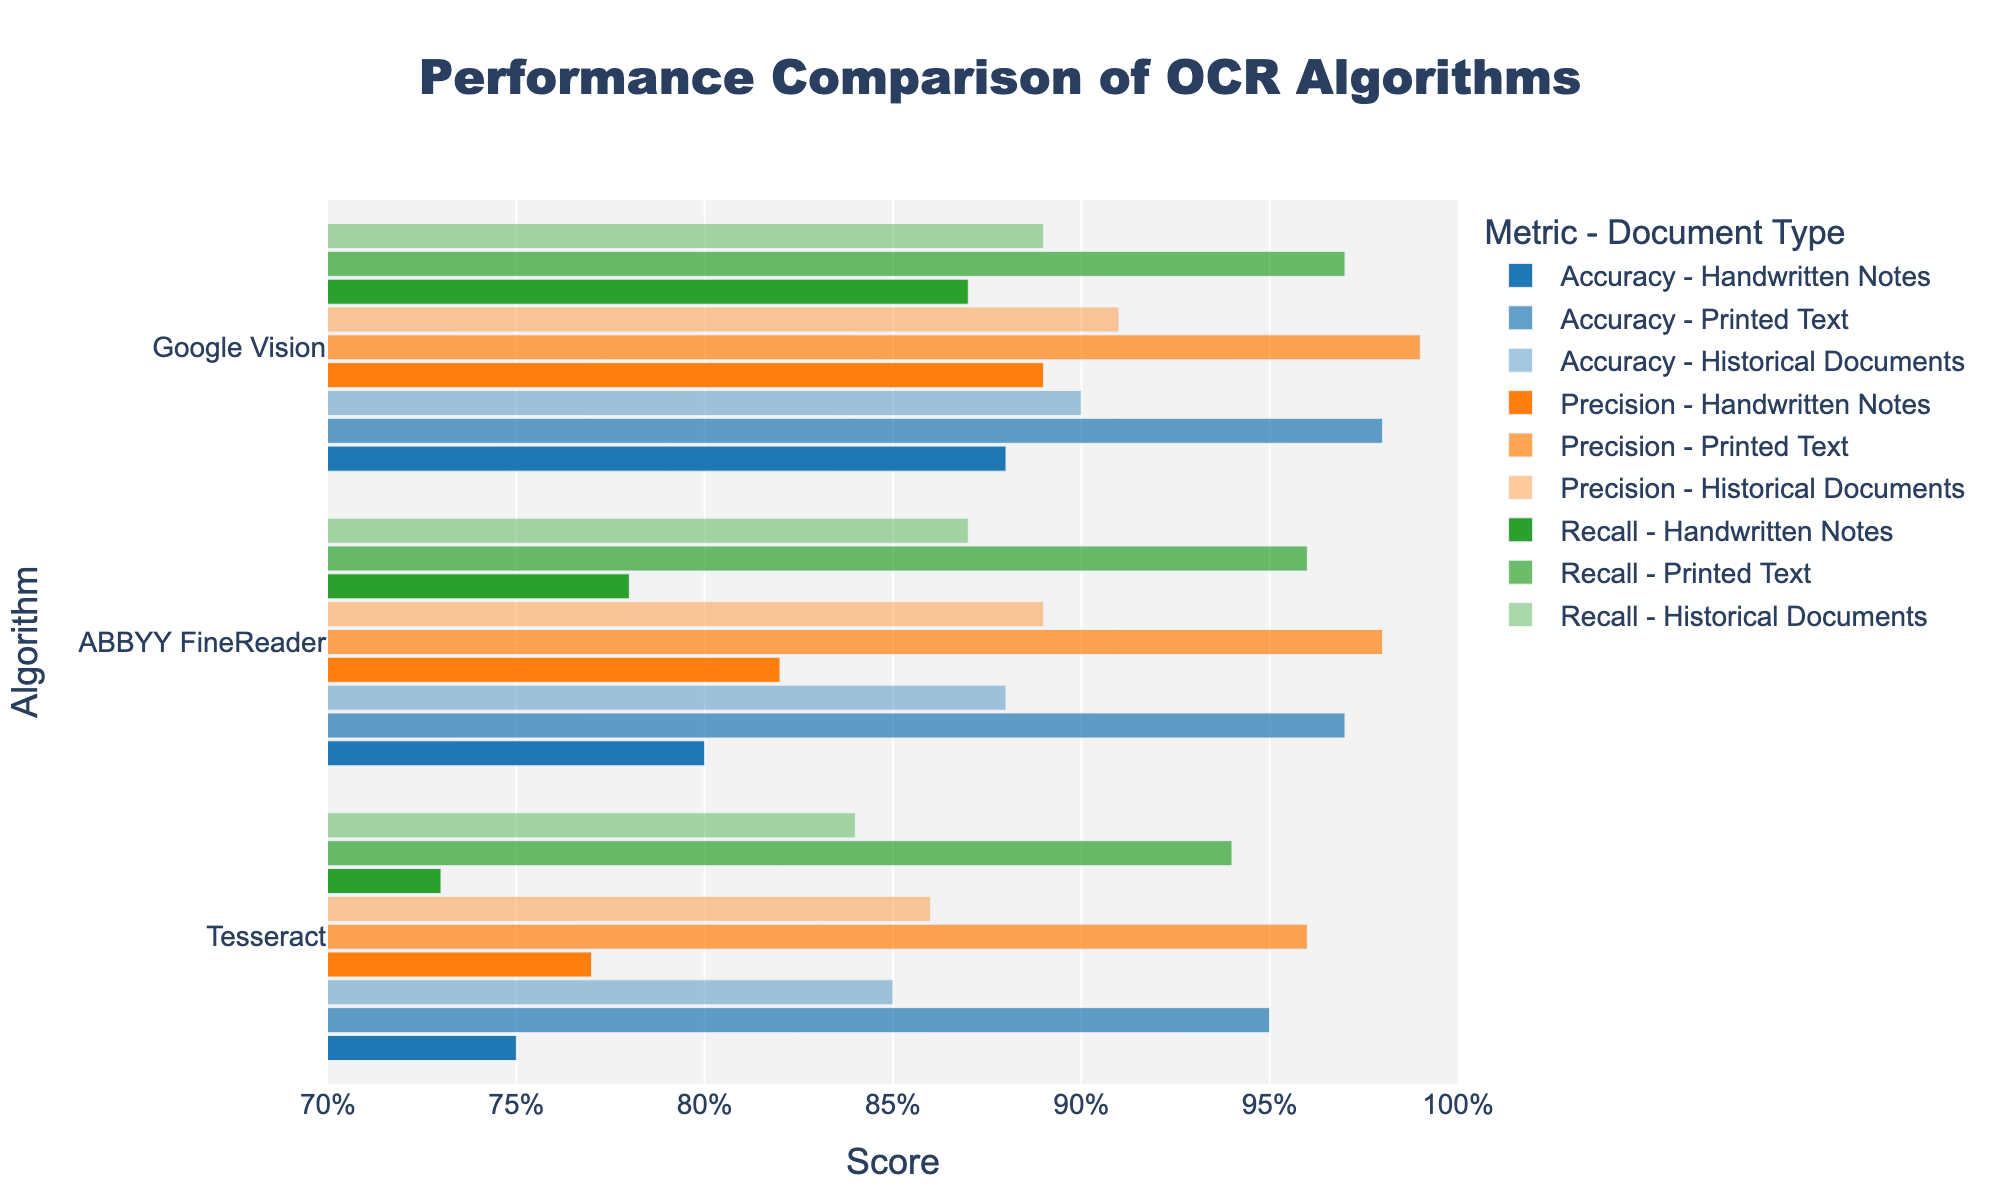Which algorithm has the highest accuracy for printed text? The figure shows the performance metrics for each algorithm and document type. The accuracy for printed text for each algorithm is indicated by the length of the blue bars in the "Printed Text" section. Google Vision has the highest accuracy with a score of 0.98.
Answer: Google Vision Which document type shows the greatest difference in precision between Tesseract and Google Vision? To find the greatest difference, compare the lengths of the orange bars (precision) for each document type, specifically for Tesseract and Google Vision. The precision for handwritten notes differs by 0.12 (0.89 - 0.77).
Answer: Handwritten Notes Which OCR algorithm performs best overall when considering all document types and metrics? To determine the best overall algorithm, we need to look at the average performance across all metrics (accuracy, precision, recall) and document types. Google Vision has consistently high scores across all metrics and document types, suggesting it performs the best overall.
Answer: Google Vision How does ABBYY FineReader's performance compare to Tesseract's for historical documents in terms of recall? Compare the green bars (recall) for historical documents between these two algorithms. ABBYY FineReader has a recall of 0.87, while Tesseract has a recall of 0.84. ABBYY FineReader performs slightly better.
Answer: ABBYY FineReader What is the range of accuracy scores for Tesseract across different document types? The accuracy scores for Tesseract can be read from the blue bars. The scores are 0.75 for handwritten notes, 0.95 for printed text, and 0.85 for historical documents. The range is calculated as the difference between the highest and lowest values: 0.95 - 0.75 = 0.20.
Answer: 0.20 Which metric shows the most variance for Google Vision across the three document types? Compare the lengths of blue (accuracy), orange (precision), and green (recall) bars for Google Vision across the document types. Accuracy ranges from 0.88 to 0.98, precision ranges from 0.89 to 0.99, and recall ranges from 0.87 to 0.97. The accuracy metric has the most variance at 0.10.
Answer: Accuracy Do any algorithms perform better on historical documents than on handwritten notes? Compare the performance metrics for each algorithm between historical documents and handwritten notes. All three algorithms (Tesseract, Google Vision, ABBYY FineReader) have higher scores on historical documents than on handwritten notes.
Answer: Yes 